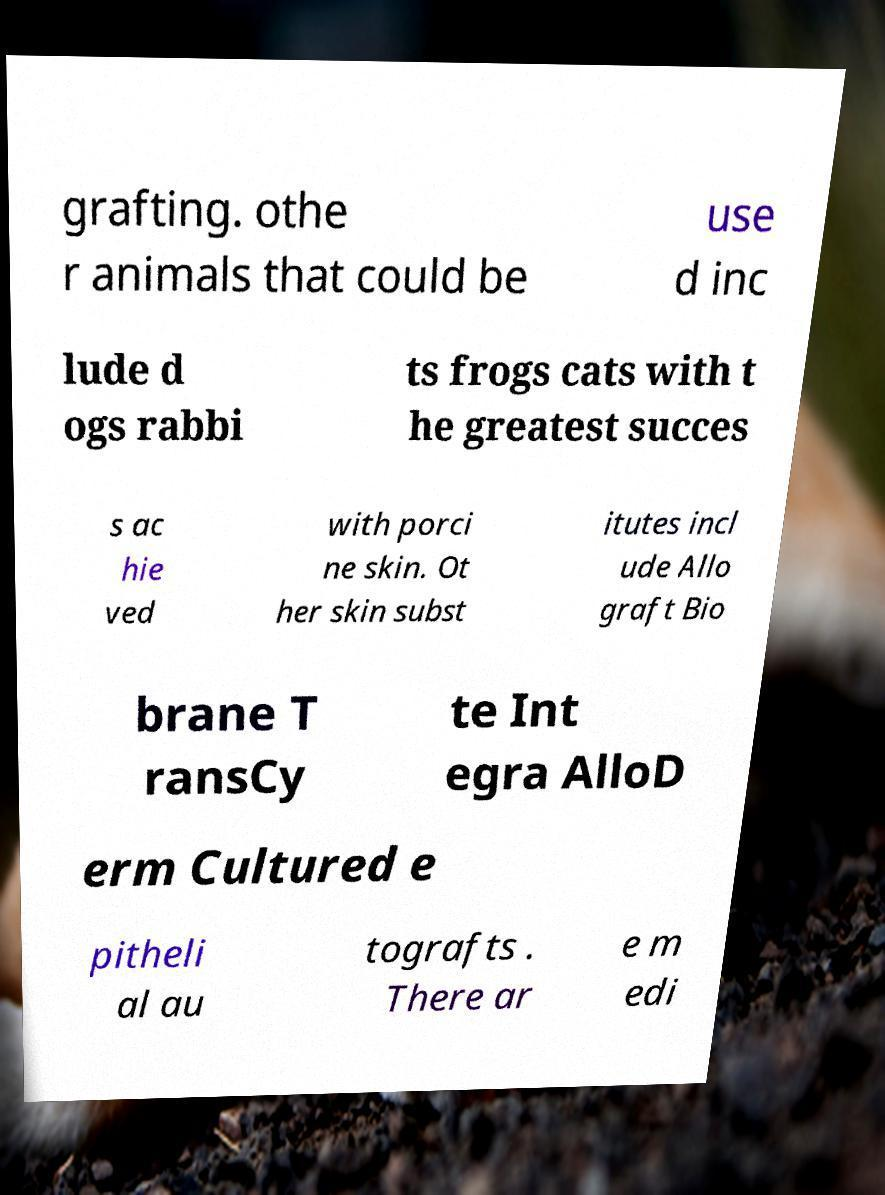For documentation purposes, I need the text within this image transcribed. Could you provide that? grafting. othe r animals that could be use d inc lude d ogs rabbi ts frogs cats with t he greatest succes s ac hie ved with porci ne skin. Ot her skin subst itutes incl ude Allo graft Bio brane T ransCy te Int egra AlloD erm Cultured e pitheli al au tografts . There ar e m edi 